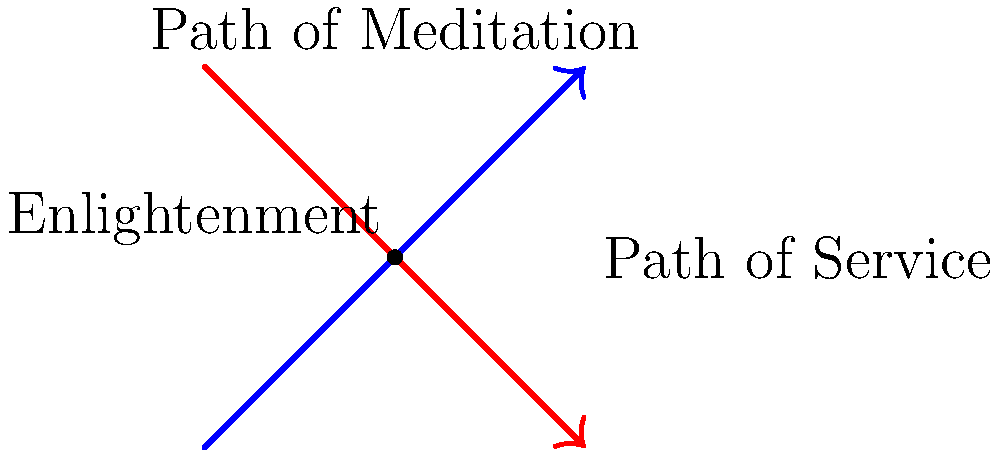In the spiritual journey towards enlightenment, two paths are represented by intersecting lines: the Path of Meditation (blue) and the Path of Service (red). The Path of Meditation is described by the equation $y = x$, while the Path of Service is described by $y = -x + 5$. At what point do these two paths intersect, symbolizing the convergence of different spiritual practices? To find the intersection point of these two paths, we need to solve the system of equations:

1) Path of Meditation: $y = x$
2) Path of Service: $y = -x + 5$

Step 1: Set the equations equal to each other
$x = -x + 5$

Step 2: Solve for x
$2x = 5$
$x = 2.5$

Step 3: Substitute this x-value into either equation to find y
Using the Path of Meditation equation: $y = x$
$y = 2.5$

Step 4: Interpret the result
The point of intersection is (2.5, 2.5). This represents the convergence of the Path of Meditation and the Path of Service, symbolizing that different spiritual practices can lead to the same point of enlightenment.

Step 5: Reflect on the spiritual meaning
This intersection reminds us that while different spiritual paths may seem divergent, they often lead to the same ultimate truth or enlightenment. It illustrates the unity in diversity of spiritual practices.
Answer: (2.5, 2.5) 